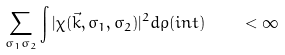<formula> <loc_0><loc_0><loc_500><loc_500>\sum _ { \sigma _ { 1 } \sigma _ { 2 } } \int \nolimits | \chi ( { \vec { k } } , \sigma _ { 1 } , \sigma _ { 2 } ) | ^ { 2 } d \rho ( i n t ) \quad < \infty</formula> 